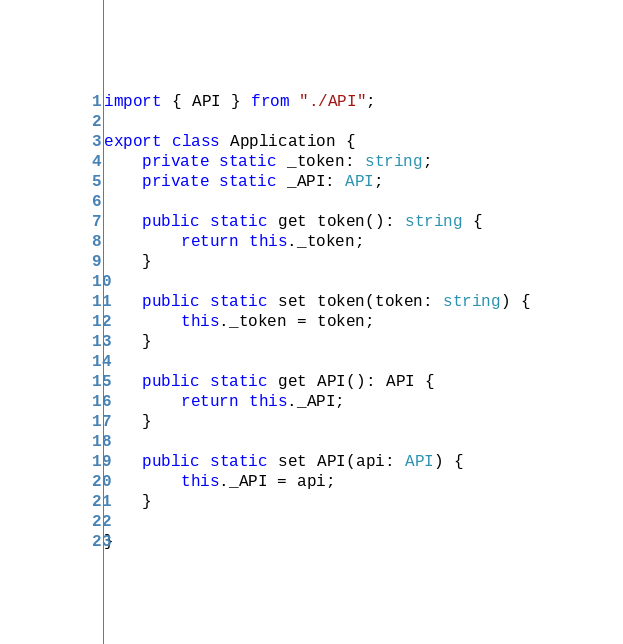<code> <loc_0><loc_0><loc_500><loc_500><_TypeScript_>import { API } from "./API";

export class Application {
    private static _token: string;
    private static _API: API;

    public static get token(): string {
        return this._token;
    }

    public static set token(token: string) {
        this._token = token;
    }

    public static get API(): API {
        return this._API;
    }

    public static set API(api: API) {
        this._API = api;
    }

}
</code> 